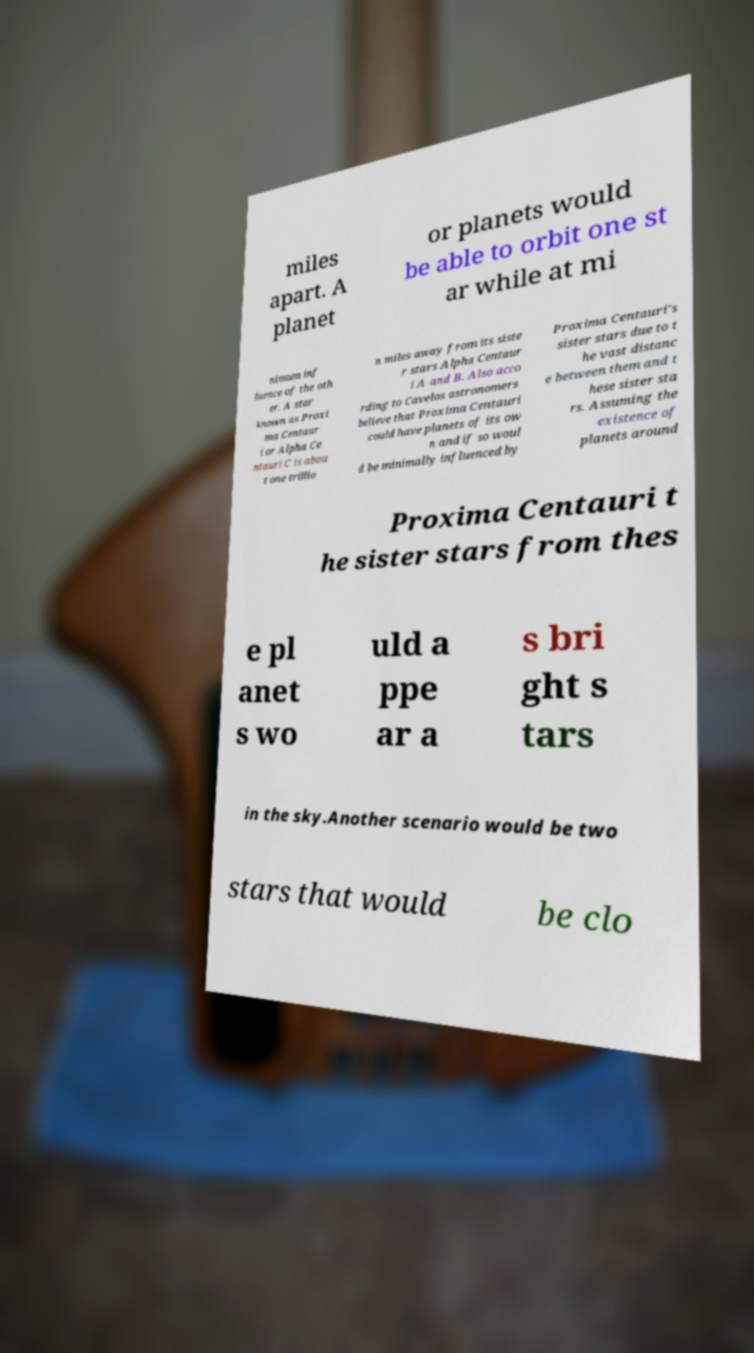There's text embedded in this image that I need extracted. Can you transcribe it verbatim? miles apart. A planet or planets would be able to orbit one st ar while at mi nimum inf luence of the oth er. A star known as Proxi ma Centaur i or Alpha Ce ntauri C is abou t one trillio n miles away from its siste r stars Alpha Centaur i A and B. Also acco rding to Cavelos astronomers believe that Proxima Centauri could have planets of its ow n and if so woul d be minimally influenced by Proxima Centauri's sister stars due to t he vast distanc e between them and t hese sister sta rs. Assuming the existence of planets around Proxima Centauri t he sister stars from thes e pl anet s wo uld a ppe ar a s bri ght s tars in the sky.Another scenario would be two stars that would be clo 